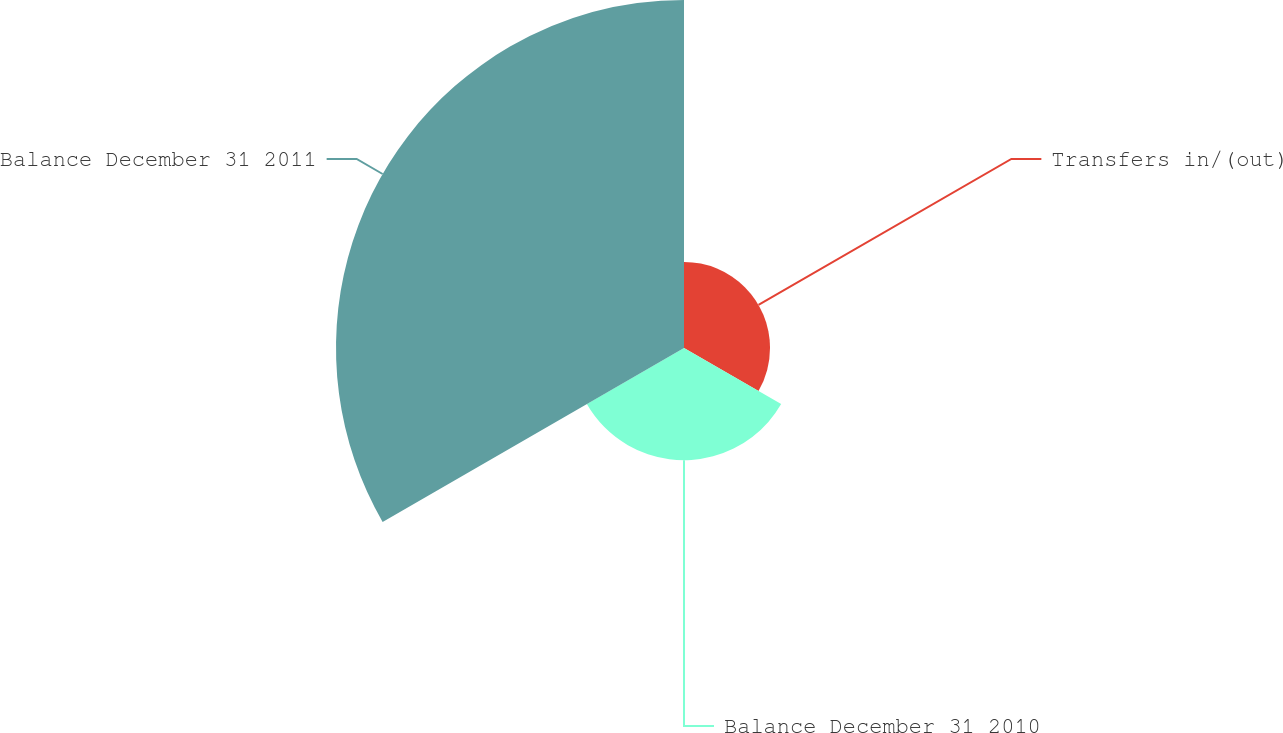Convert chart to OTSL. <chart><loc_0><loc_0><loc_500><loc_500><pie_chart><fcel>Transfers in/(out)<fcel>Balance December 31 2010<fcel>Balance December 31 2011<nl><fcel>15.75%<fcel>20.54%<fcel>63.71%<nl></chart> 